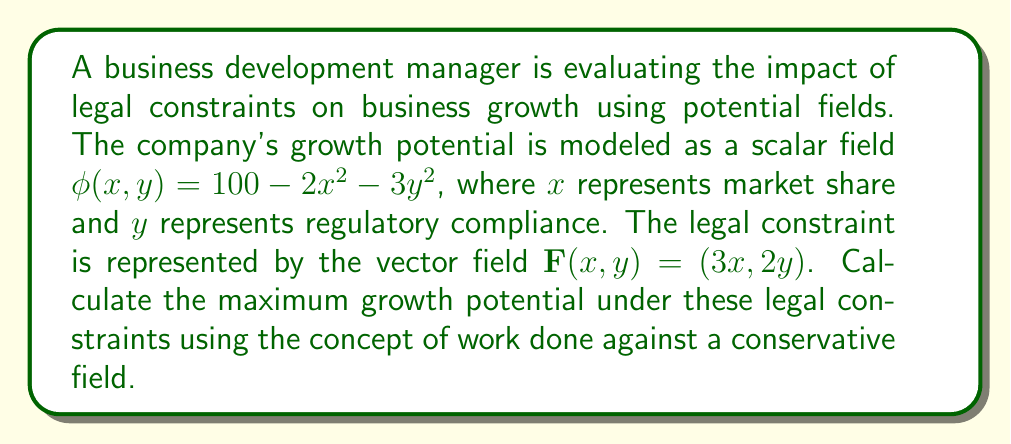Show me your answer to this math problem. 1. First, we need to determine if $\mathbf{F}$ is a conservative field. We can do this by checking if $\nabla \times \mathbf{F} = 0$:

   $\nabla \times \mathbf{F} = \frac{\partial F_y}{\partial x} - \frac{\partial F_x}{\partial y} = \frac{\partial (2y)}{\partial x} - \frac{\partial (3x)}{\partial y} = 0 - 0 = 0$

   Since $\nabla \times \mathbf{F} = 0$, $\mathbf{F}$ is conservative.

2. For a conservative field, there exists a potential function $V(x,y)$ such that $\mathbf{F} = -\nabla V$. We can find $V$ by integrating:

   $V(x,y) = -\int F_x dx - \int F_y dy = -\int 3x dx - \int 2y dy = -\frac{3}{2}x^2 - y^2 + C$

3. The work done against the field $\mathbf{F}$ is equal to the change in potential energy:

   $W = V(x_2, y_2) - V(x_1, y_1)$

4. The maximum growth potential occurs at the point $(0,0)$ where $\phi(0,0) = 100$. We need to find the work done to reach this point from any other point $(x,y)$:

   $W = V(0,0) - V(x,y) = (0 + C) - (-\frac{3}{2}x^2 - y^2 + C) = \frac{3}{2}x^2 + y^2$

5. The total potential at any point $(x,y)$ under the legal constraints is:

   $\text{Total Potential} = \phi(x,y) - W = (100 - 2x^2 - 3y^2) - (\frac{3}{2}x^2 + y^2)$

6. Simplifying:

   $\text{Total Potential} = 100 - \frac{7}{2}x^2 - 4y^2$

7. The maximum of this function occurs at $(0,0)$, where the total potential is 100.
Answer: 100 